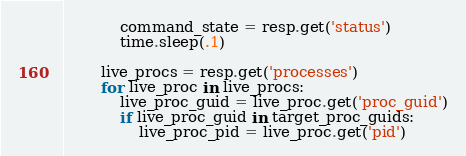<code> <loc_0><loc_0><loc_500><loc_500><_Python_>            command_state = resp.get('status')
            time.sleep(.1)

        live_procs = resp.get('processes')
        for live_proc in live_procs:
            live_proc_guid = live_proc.get('proc_guid')
            if live_proc_guid in target_proc_guids:
                live_proc_pid = live_proc.get('pid')</code> 